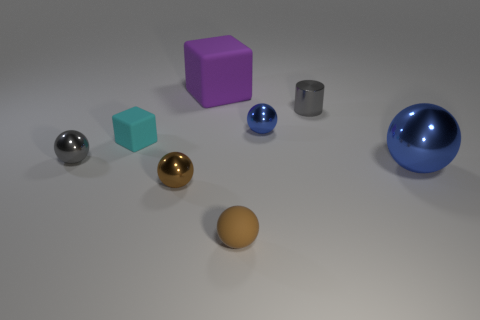Is the material of the big blue thing the same as the blue object behind the large metallic thing?
Provide a succinct answer. Yes. There is a blue metallic object that is left of the big metal sphere; is its shape the same as the cyan thing?
Your answer should be compact. No. There is a big object that is the same shape as the small brown rubber object; what material is it?
Your answer should be compact. Metal. Does the tiny blue metal thing have the same shape as the object in front of the brown metallic sphere?
Your answer should be very brief. Yes. The small sphere that is both behind the brown metal thing and on the left side of the big purple thing is what color?
Make the answer very short. Gray. Is there a small brown object?
Provide a short and direct response. Yes. Are there an equal number of tiny cyan cubes that are in front of the small brown matte ball and green matte balls?
Give a very brief answer. Yes. How many other objects are there of the same shape as the large rubber thing?
Your response must be concise. 1. There is a small brown shiny object; what shape is it?
Provide a succinct answer. Sphere. Do the big cube and the tiny blue ball have the same material?
Provide a succinct answer. No. 